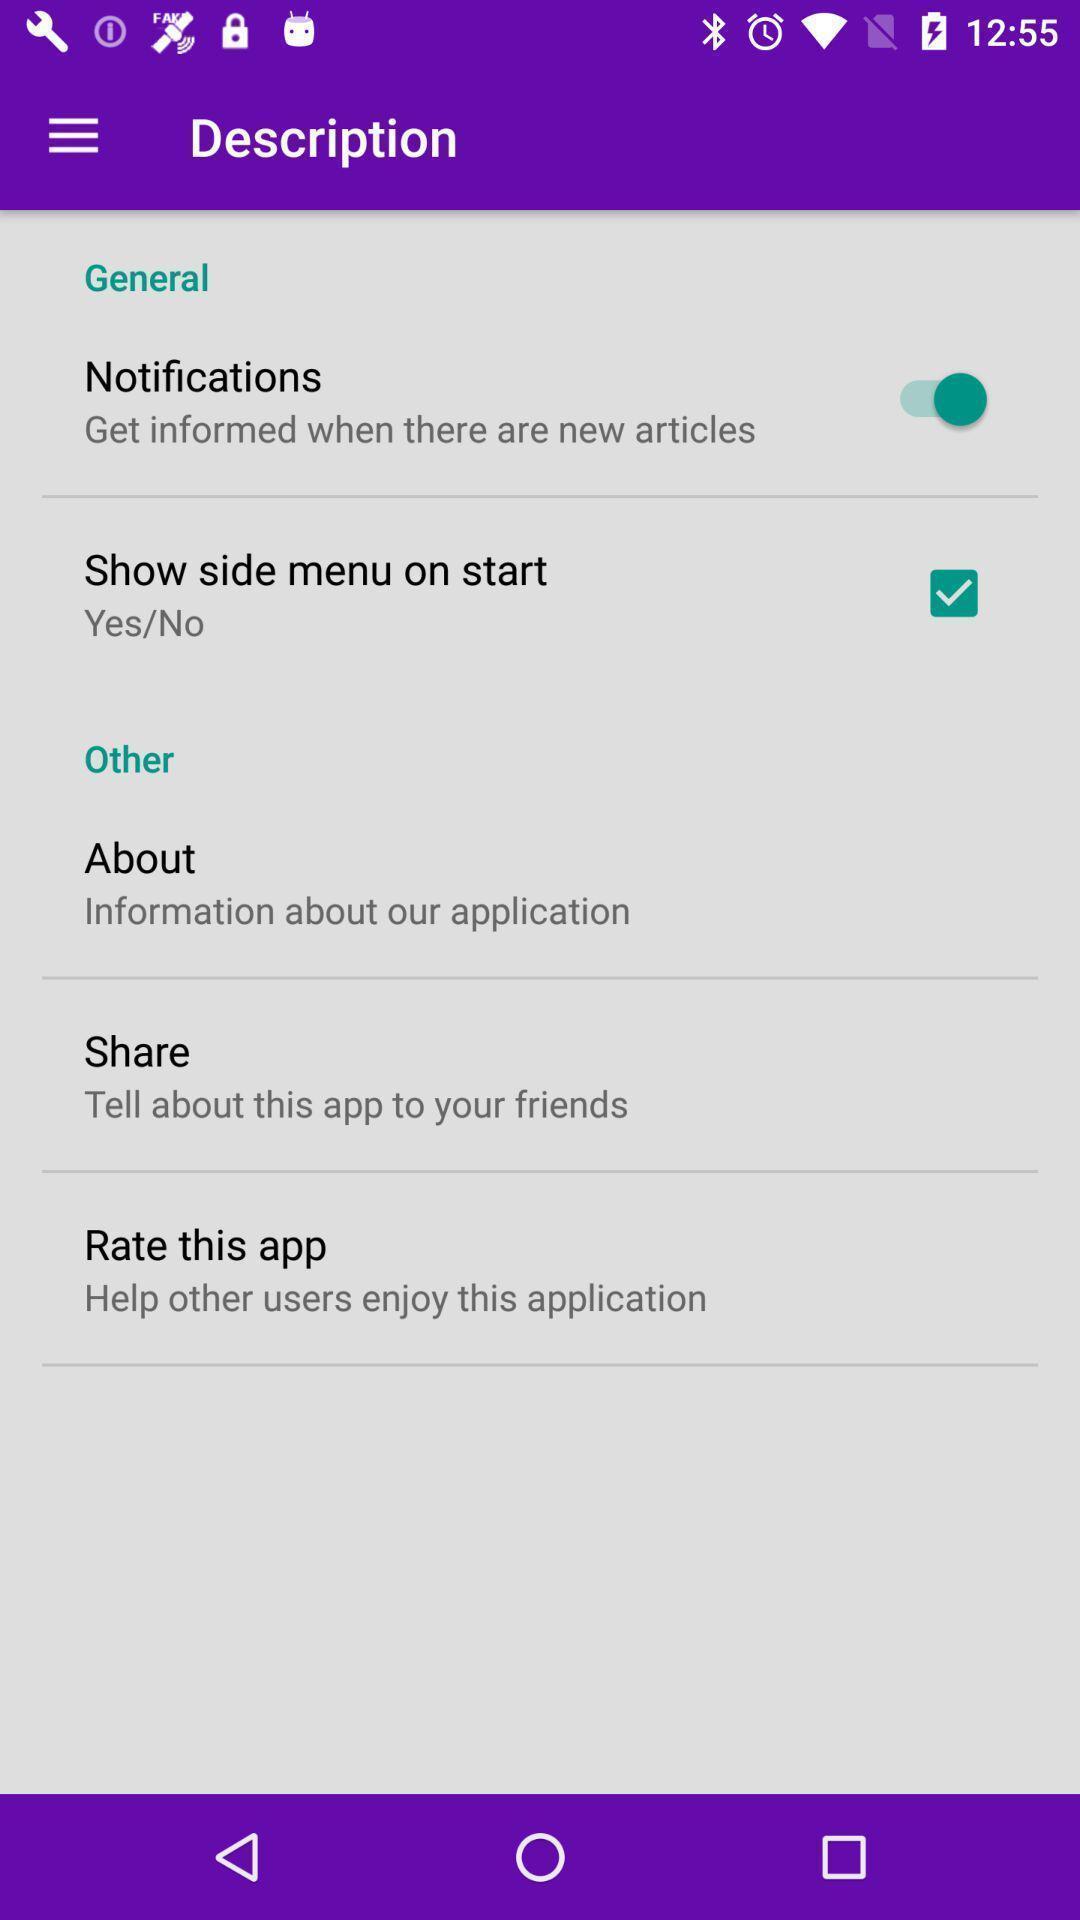Tell me what you see in this picture. Screen showing description. 